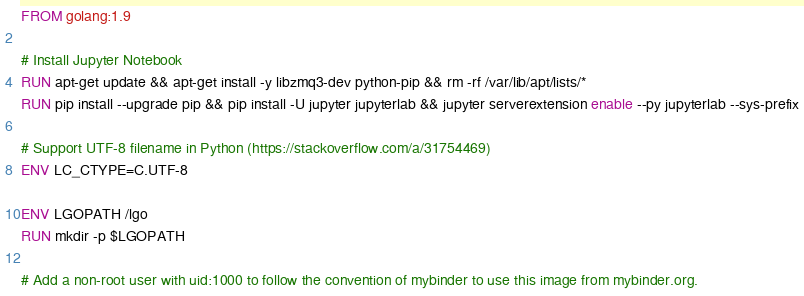Convert code to text. <code><loc_0><loc_0><loc_500><loc_500><_Dockerfile_>FROM golang:1.9

# Install Jupyter Notebook
RUN apt-get update && apt-get install -y libzmq3-dev python-pip && rm -rf /var/lib/apt/lists/*
RUN pip install --upgrade pip && pip install -U jupyter jupyterlab && jupyter serverextension enable --py jupyterlab --sys-prefix

# Support UTF-8 filename in Python (https://stackoverflow.com/a/31754469)
ENV LC_CTYPE=C.UTF-8

ENV LGOPATH /lgo
RUN mkdir -p $LGOPATH

# Add a non-root user with uid:1000 to follow the convention of mybinder to use this image from mybinder.org.</code> 